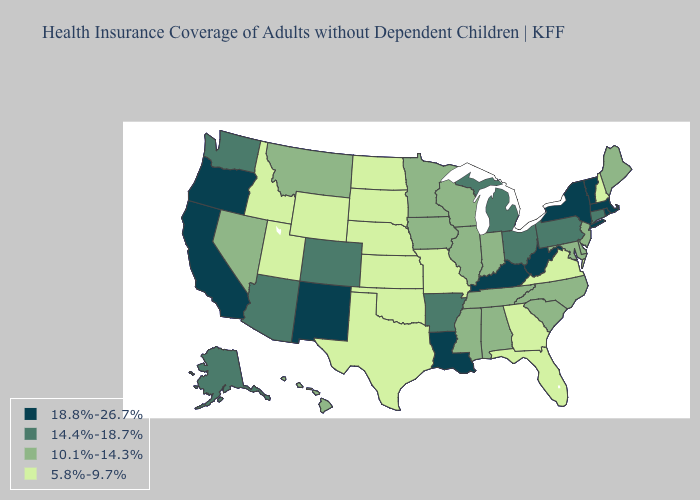Among the states that border Massachusetts , does Connecticut have the highest value?
Answer briefly. No. Among the states that border Utah , does New Mexico have the highest value?
Give a very brief answer. Yes. Name the states that have a value in the range 5.8%-9.7%?
Keep it brief. Florida, Georgia, Idaho, Kansas, Missouri, Nebraska, New Hampshire, North Dakota, Oklahoma, South Dakota, Texas, Utah, Virginia, Wyoming. Name the states that have a value in the range 10.1%-14.3%?
Answer briefly. Alabama, Delaware, Hawaii, Illinois, Indiana, Iowa, Maine, Maryland, Minnesota, Mississippi, Montana, Nevada, New Jersey, North Carolina, South Carolina, Tennessee, Wisconsin. Name the states that have a value in the range 10.1%-14.3%?
Concise answer only. Alabama, Delaware, Hawaii, Illinois, Indiana, Iowa, Maine, Maryland, Minnesota, Mississippi, Montana, Nevada, New Jersey, North Carolina, South Carolina, Tennessee, Wisconsin. What is the lowest value in the West?
Write a very short answer. 5.8%-9.7%. Among the states that border Vermont , which have the highest value?
Be succinct. Massachusetts, New York. What is the lowest value in states that border Nevada?
Write a very short answer. 5.8%-9.7%. What is the value of Wyoming?
Concise answer only. 5.8%-9.7%. What is the value of Georgia?
Short answer required. 5.8%-9.7%. Name the states that have a value in the range 14.4%-18.7%?
Be succinct. Alaska, Arizona, Arkansas, Colorado, Connecticut, Michigan, Ohio, Pennsylvania, Washington. What is the value of Nevada?
Concise answer only. 10.1%-14.3%. What is the value of Washington?
Write a very short answer. 14.4%-18.7%. What is the highest value in the MidWest ?
Answer briefly. 14.4%-18.7%. What is the lowest value in the Northeast?
Keep it brief. 5.8%-9.7%. 